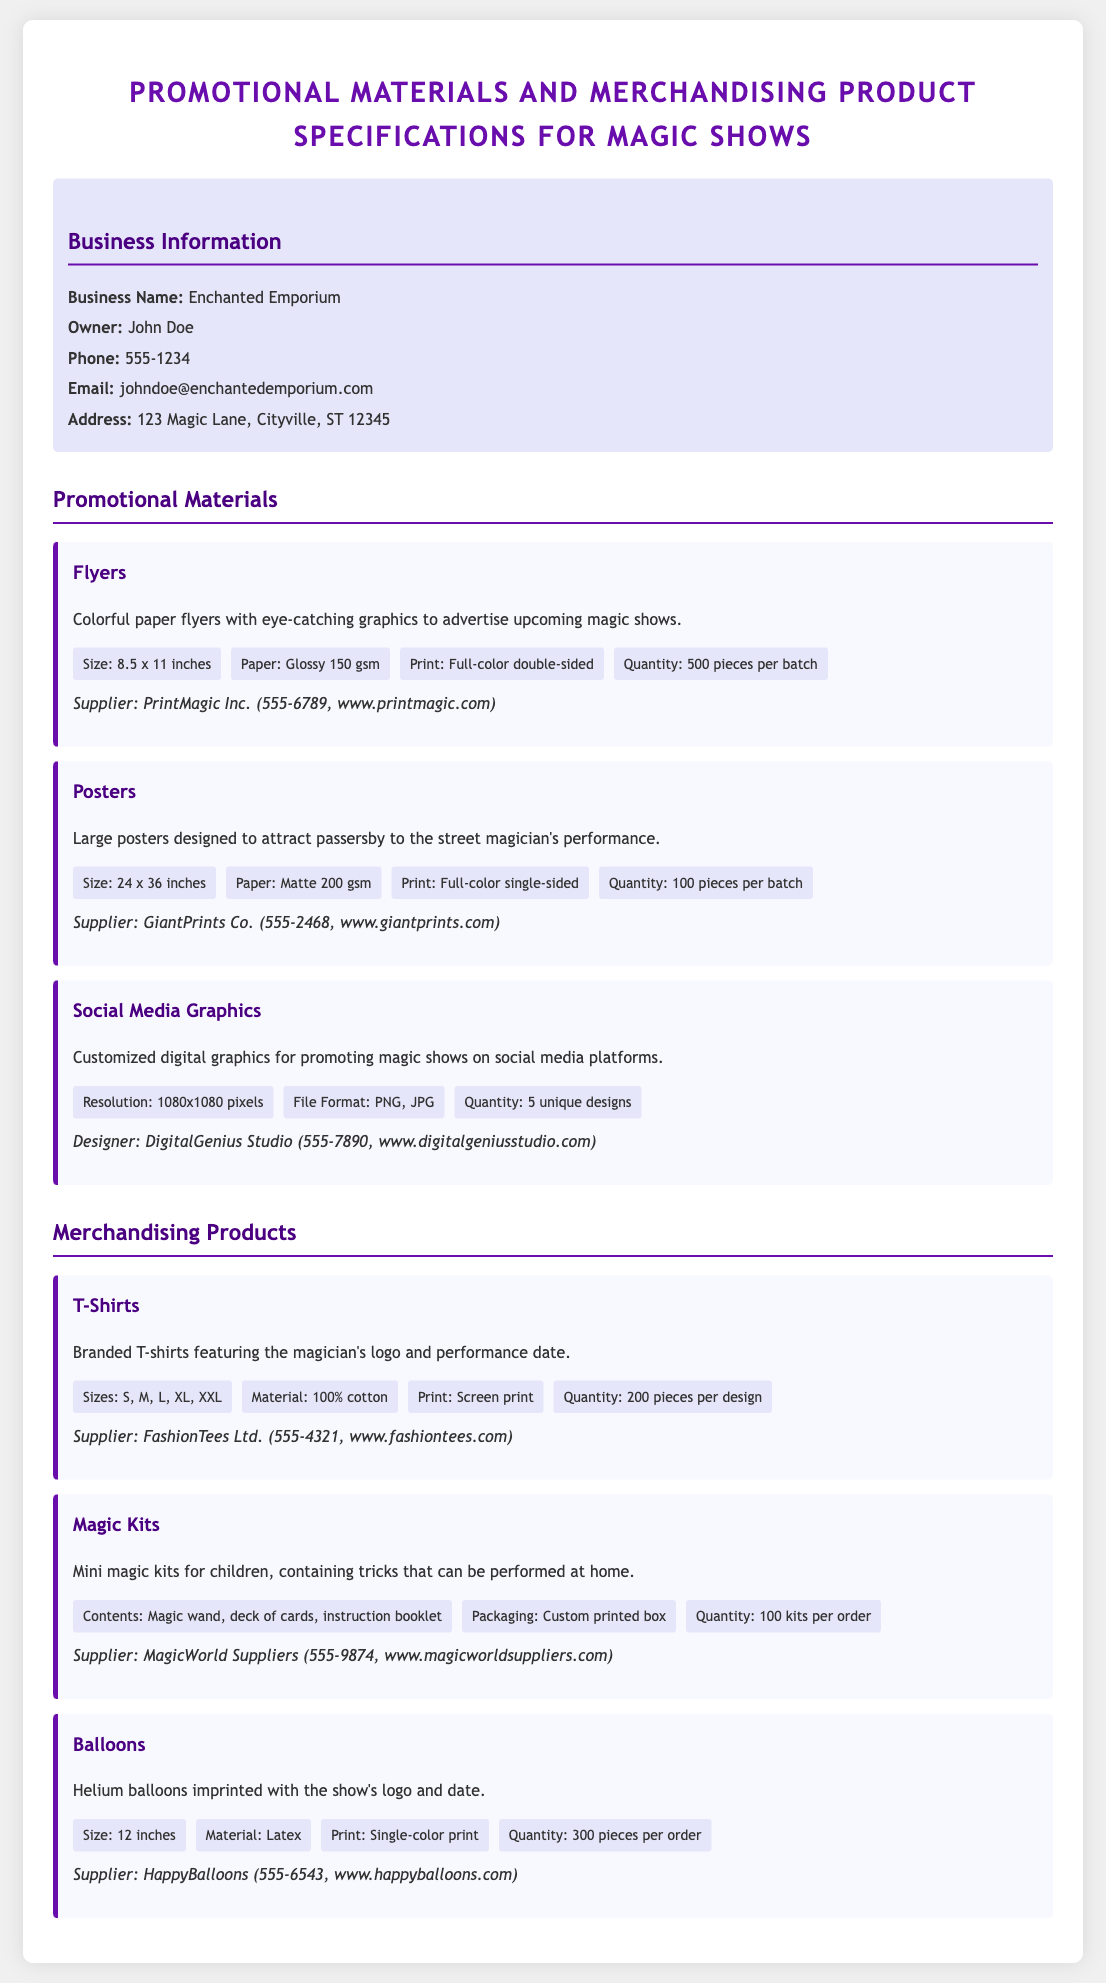what is the business name? The business name is stated in the contact information section of the document.
Answer: Enchanted Emporium who is the owner? The owner's name is provided in the contact information section.
Answer: John Doe what is the quantity of flyers per batch? The quantity specification for flyers is listed in the promotional materials section.
Answer: 500 pieces per batch what is the size of the posters? The size specification for posters is detailed in the promotional materials section.
Answer: 24 x 36 inches how many unique designs of social media graphics are included? The quantity of unique designs for social media graphics is specified in the promotional materials section.
Answer: 5 unique designs what is the material of the T-shirts? The material used for T-shirts is mentioned in the merchandising products section.
Answer: 100% cotton what is the size of the balloons? The size of the balloons is provided in the merchandising products section.
Answer: 12 inches which supplier provides the magic kits? The supplier information for magic kits is stated in the merchandising products section.
Answer: MagicWorld Suppliers what is the print type for the posters? The printing specification for the posters is included in the promotional materials section.
Answer: Full-color single-sided 